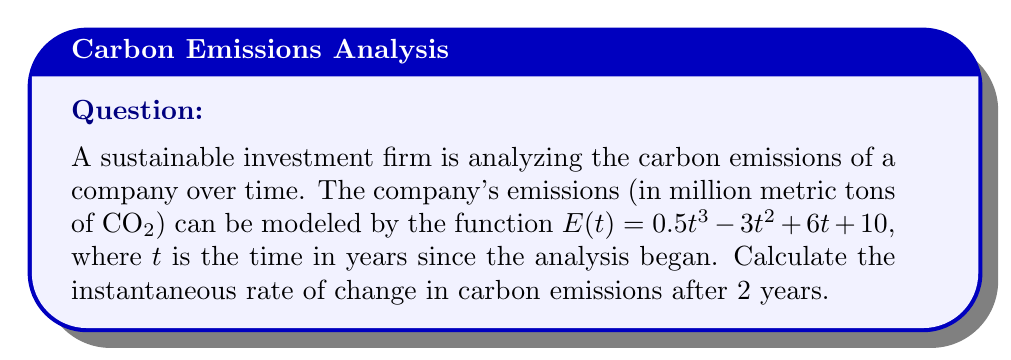Show me your answer to this math problem. To find the instantaneous rate of change in carbon emissions after 2 years, we need to follow these steps:

1) The rate of change is given by the derivative of the function $E(t)$.

2) Let's find the derivative $E'(t)$:
   $$E'(t) = \frac{d}{dt}(0.5t^3 - 3t^2 + 6t + 10)$$
   $$E'(t) = 1.5t^2 - 6t + 6$$

3) Now, we need to evaluate $E'(t)$ at $t = 2$:
   $$E'(2) = 1.5(2)^2 - 6(2) + 6$$
   $$E'(2) = 1.5(4) - 12 + 6$$
   $$E'(2) = 6 - 12 + 6$$
   $$E'(2) = 0$$

4) The units for this rate of change would be million metric tons of CO2 per year.
Answer: 0 million metric tons of CO2 per year 